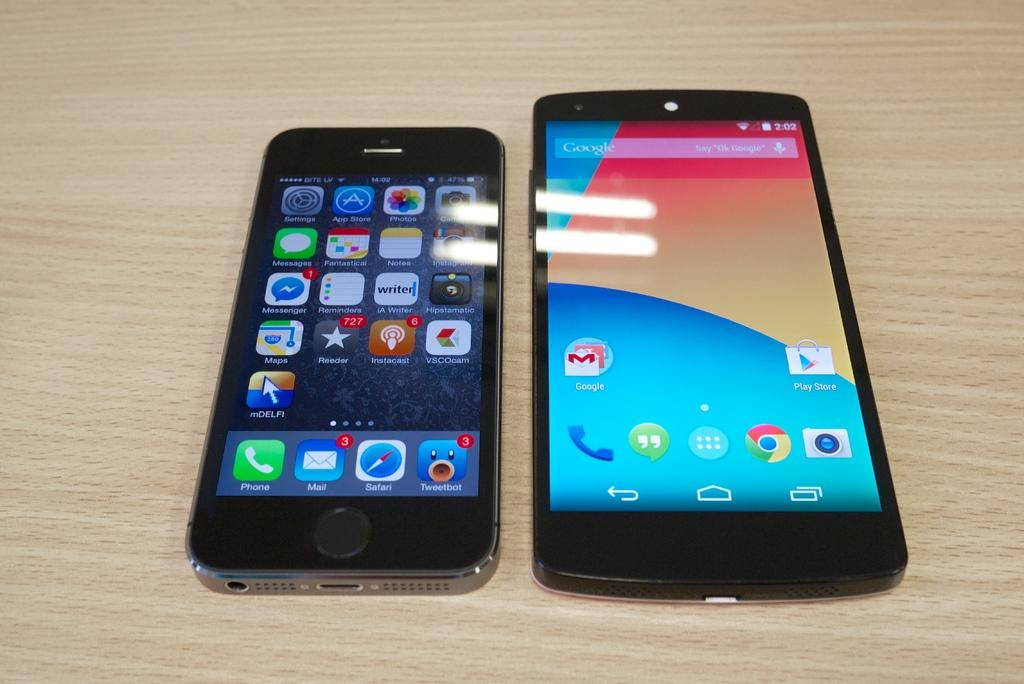What electronic devices are visible in the image? There are mobile phones in the image. Where are the mobile phones located? The mobile phones are on a table. What type of amusement can be seen in the image? There is no amusement present in the image; it only features mobile phones on a table. How many legs does the table have in the image? The image does not provide enough information to determine the number of legs on the table. 